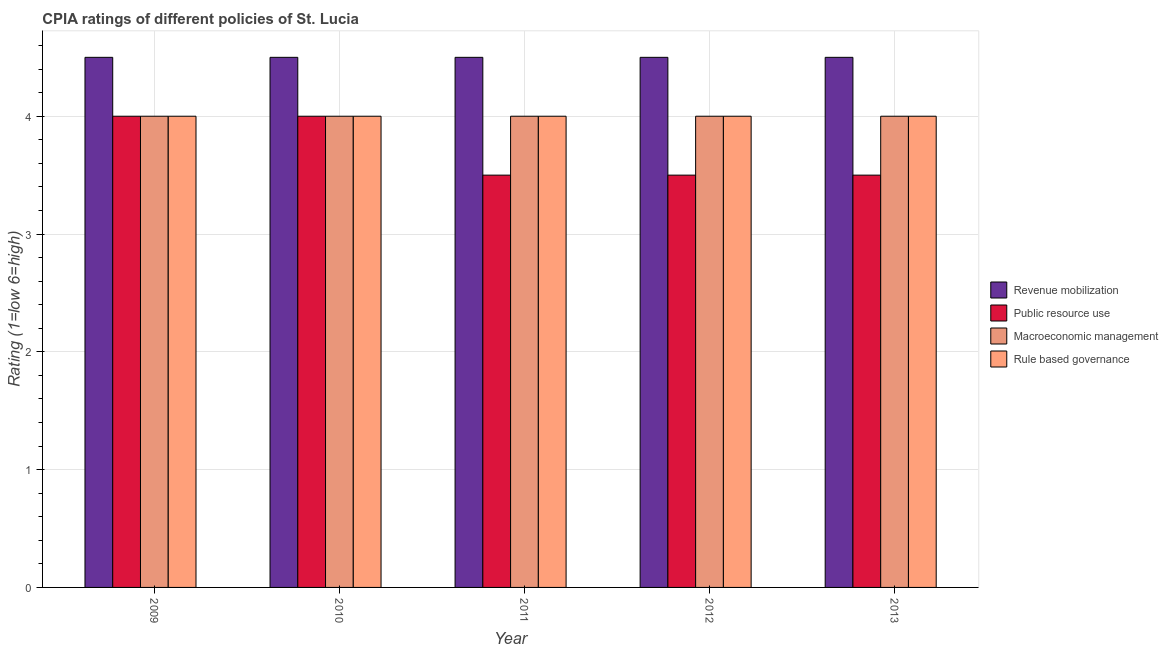How many different coloured bars are there?
Keep it short and to the point. 4. Are the number of bars per tick equal to the number of legend labels?
Your answer should be compact. Yes. Are the number of bars on each tick of the X-axis equal?
Your response must be concise. Yes. How many bars are there on the 5th tick from the left?
Give a very brief answer. 4. What is the label of the 4th group of bars from the left?
Provide a succinct answer. 2012. In how many cases, is the number of bars for a given year not equal to the number of legend labels?
Provide a succinct answer. 0. What is the cpia rating of public resource use in 2012?
Offer a terse response. 3.5. Across all years, what is the maximum cpia rating of rule based governance?
Provide a succinct answer. 4. Across all years, what is the minimum cpia rating of macroeconomic management?
Make the answer very short. 4. In which year was the cpia rating of revenue mobilization minimum?
Offer a terse response. 2009. What is the total cpia rating of public resource use in the graph?
Your answer should be compact. 18.5. What is the difference between the cpia rating of macroeconomic management in 2012 and the cpia rating of rule based governance in 2013?
Provide a short and direct response. 0. In the year 2010, what is the difference between the cpia rating of public resource use and cpia rating of revenue mobilization?
Provide a succinct answer. 0. In how many years, is the cpia rating of revenue mobilization greater than 1.2?
Ensure brevity in your answer.  5. What is the ratio of the cpia rating of revenue mobilization in 2009 to that in 2013?
Give a very brief answer. 1. Is the difference between the cpia rating of macroeconomic management in 2009 and 2011 greater than the difference between the cpia rating of public resource use in 2009 and 2011?
Give a very brief answer. No. What is the difference between the highest and the second highest cpia rating of revenue mobilization?
Provide a succinct answer. 0. What is the difference between the highest and the lowest cpia rating of revenue mobilization?
Your answer should be very brief. 0. Is it the case that in every year, the sum of the cpia rating of revenue mobilization and cpia rating of public resource use is greater than the sum of cpia rating of rule based governance and cpia rating of macroeconomic management?
Your answer should be compact. Yes. What does the 3rd bar from the left in 2010 represents?
Your response must be concise. Macroeconomic management. What does the 3rd bar from the right in 2009 represents?
Offer a terse response. Public resource use. Are all the bars in the graph horizontal?
Give a very brief answer. No. How many years are there in the graph?
Your answer should be compact. 5. Are the values on the major ticks of Y-axis written in scientific E-notation?
Provide a succinct answer. No. Does the graph contain grids?
Your response must be concise. Yes. Where does the legend appear in the graph?
Your answer should be very brief. Center right. How many legend labels are there?
Offer a very short reply. 4. What is the title of the graph?
Provide a succinct answer. CPIA ratings of different policies of St. Lucia. Does "Quality Certification" appear as one of the legend labels in the graph?
Offer a terse response. No. What is the label or title of the X-axis?
Keep it short and to the point. Year. What is the Rating (1=low 6=high) in Revenue mobilization in 2009?
Give a very brief answer. 4.5. What is the Rating (1=low 6=high) in Public resource use in 2009?
Provide a succinct answer. 4. What is the Rating (1=low 6=high) of Macroeconomic management in 2009?
Keep it short and to the point. 4. What is the Rating (1=low 6=high) in Rule based governance in 2009?
Ensure brevity in your answer.  4. What is the Rating (1=low 6=high) of Macroeconomic management in 2011?
Your response must be concise. 4. What is the Rating (1=low 6=high) in Revenue mobilization in 2012?
Ensure brevity in your answer.  4.5. What is the Rating (1=low 6=high) of Public resource use in 2013?
Keep it short and to the point. 3.5. What is the Rating (1=low 6=high) of Macroeconomic management in 2013?
Make the answer very short. 4. Across all years, what is the maximum Rating (1=low 6=high) of Revenue mobilization?
Offer a terse response. 4.5. Across all years, what is the maximum Rating (1=low 6=high) in Macroeconomic management?
Offer a terse response. 4. Across all years, what is the minimum Rating (1=low 6=high) in Revenue mobilization?
Provide a succinct answer. 4.5. Across all years, what is the minimum Rating (1=low 6=high) in Public resource use?
Offer a very short reply. 3.5. Across all years, what is the minimum Rating (1=low 6=high) in Rule based governance?
Your answer should be very brief. 4. What is the total Rating (1=low 6=high) of Revenue mobilization in the graph?
Offer a very short reply. 22.5. What is the total Rating (1=low 6=high) in Public resource use in the graph?
Give a very brief answer. 18.5. What is the difference between the Rating (1=low 6=high) in Revenue mobilization in 2009 and that in 2010?
Your answer should be very brief. 0. What is the difference between the Rating (1=low 6=high) of Public resource use in 2009 and that in 2010?
Provide a succinct answer. 0. What is the difference between the Rating (1=low 6=high) of Rule based governance in 2009 and that in 2010?
Make the answer very short. 0. What is the difference between the Rating (1=low 6=high) in Revenue mobilization in 2009 and that in 2011?
Make the answer very short. 0. What is the difference between the Rating (1=low 6=high) in Public resource use in 2009 and that in 2011?
Your answer should be very brief. 0.5. What is the difference between the Rating (1=low 6=high) of Public resource use in 2009 and that in 2012?
Provide a short and direct response. 0.5. What is the difference between the Rating (1=low 6=high) in Macroeconomic management in 2009 and that in 2012?
Make the answer very short. 0. What is the difference between the Rating (1=low 6=high) of Rule based governance in 2009 and that in 2012?
Provide a succinct answer. 0. What is the difference between the Rating (1=low 6=high) of Revenue mobilization in 2009 and that in 2013?
Your answer should be compact. 0. What is the difference between the Rating (1=low 6=high) in Public resource use in 2009 and that in 2013?
Your answer should be compact. 0.5. What is the difference between the Rating (1=low 6=high) of Macroeconomic management in 2009 and that in 2013?
Your response must be concise. 0. What is the difference between the Rating (1=low 6=high) of Rule based governance in 2009 and that in 2013?
Provide a succinct answer. 0. What is the difference between the Rating (1=low 6=high) in Rule based governance in 2010 and that in 2011?
Make the answer very short. 0. What is the difference between the Rating (1=low 6=high) in Revenue mobilization in 2010 and that in 2012?
Offer a very short reply. 0. What is the difference between the Rating (1=low 6=high) of Revenue mobilization in 2010 and that in 2013?
Keep it short and to the point. 0. What is the difference between the Rating (1=low 6=high) of Public resource use in 2011 and that in 2012?
Your answer should be compact. 0. What is the difference between the Rating (1=low 6=high) of Macroeconomic management in 2011 and that in 2012?
Your answer should be compact. 0. What is the difference between the Rating (1=low 6=high) of Public resource use in 2012 and that in 2013?
Your answer should be very brief. 0. What is the difference between the Rating (1=low 6=high) of Macroeconomic management in 2012 and that in 2013?
Offer a terse response. 0. What is the difference between the Rating (1=low 6=high) in Revenue mobilization in 2009 and the Rating (1=low 6=high) in Public resource use in 2010?
Offer a very short reply. 0.5. What is the difference between the Rating (1=low 6=high) of Revenue mobilization in 2009 and the Rating (1=low 6=high) of Macroeconomic management in 2010?
Offer a very short reply. 0.5. What is the difference between the Rating (1=low 6=high) in Public resource use in 2009 and the Rating (1=low 6=high) in Macroeconomic management in 2010?
Provide a short and direct response. 0. What is the difference between the Rating (1=low 6=high) in Public resource use in 2009 and the Rating (1=low 6=high) in Rule based governance in 2010?
Offer a very short reply. 0. What is the difference between the Rating (1=low 6=high) in Macroeconomic management in 2009 and the Rating (1=low 6=high) in Rule based governance in 2010?
Ensure brevity in your answer.  0. What is the difference between the Rating (1=low 6=high) of Revenue mobilization in 2009 and the Rating (1=low 6=high) of Macroeconomic management in 2011?
Provide a succinct answer. 0.5. What is the difference between the Rating (1=low 6=high) in Revenue mobilization in 2009 and the Rating (1=low 6=high) in Rule based governance in 2011?
Provide a succinct answer. 0.5. What is the difference between the Rating (1=low 6=high) in Public resource use in 2009 and the Rating (1=low 6=high) in Macroeconomic management in 2011?
Provide a short and direct response. 0. What is the difference between the Rating (1=low 6=high) in Public resource use in 2009 and the Rating (1=low 6=high) in Rule based governance in 2011?
Make the answer very short. 0. What is the difference between the Rating (1=low 6=high) in Macroeconomic management in 2009 and the Rating (1=low 6=high) in Rule based governance in 2011?
Offer a terse response. 0. What is the difference between the Rating (1=low 6=high) of Revenue mobilization in 2009 and the Rating (1=low 6=high) of Macroeconomic management in 2012?
Ensure brevity in your answer.  0.5. What is the difference between the Rating (1=low 6=high) in Public resource use in 2009 and the Rating (1=low 6=high) in Rule based governance in 2012?
Your answer should be compact. 0. What is the difference between the Rating (1=low 6=high) of Public resource use in 2009 and the Rating (1=low 6=high) of Macroeconomic management in 2013?
Make the answer very short. 0. What is the difference between the Rating (1=low 6=high) of Public resource use in 2009 and the Rating (1=low 6=high) of Rule based governance in 2013?
Your answer should be compact. 0. What is the difference between the Rating (1=low 6=high) of Revenue mobilization in 2010 and the Rating (1=low 6=high) of Rule based governance in 2011?
Keep it short and to the point. 0.5. What is the difference between the Rating (1=low 6=high) of Public resource use in 2010 and the Rating (1=low 6=high) of Rule based governance in 2011?
Your answer should be compact. 0. What is the difference between the Rating (1=low 6=high) of Macroeconomic management in 2010 and the Rating (1=low 6=high) of Rule based governance in 2011?
Make the answer very short. 0. What is the difference between the Rating (1=low 6=high) in Revenue mobilization in 2010 and the Rating (1=low 6=high) in Macroeconomic management in 2012?
Ensure brevity in your answer.  0.5. What is the difference between the Rating (1=low 6=high) of Macroeconomic management in 2010 and the Rating (1=low 6=high) of Rule based governance in 2012?
Ensure brevity in your answer.  0. What is the difference between the Rating (1=low 6=high) of Revenue mobilization in 2010 and the Rating (1=low 6=high) of Macroeconomic management in 2013?
Offer a terse response. 0.5. What is the difference between the Rating (1=low 6=high) in Public resource use in 2010 and the Rating (1=low 6=high) in Macroeconomic management in 2013?
Provide a short and direct response. 0. What is the difference between the Rating (1=low 6=high) of Public resource use in 2011 and the Rating (1=low 6=high) of Rule based governance in 2012?
Provide a short and direct response. -0.5. What is the difference between the Rating (1=low 6=high) of Macroeconomic management in 2011 and the Rating (1=low 6=high) of Rule based governance in 2013?
Your answer should be very brief. 0. What is the difference between the Rating (1=low 6=high) of Revenue mobilization in 2012 and the Rating (1=low 6=high) of Public resource use in 2013?
Provide a succinct answer. 1. What is the difference between the Rating (1=low 6=high) in Revenue mobilization in 2012 and the Rating (1=low 6=high) in Rule based governance in 2013?
Ensure brevity in your answer.  0.5. What is the difference between the Rating (1=low 6=high) in Public resource use in 2012 and the Rating (1=low 6=high) in Rule based governance in 2013?
Provide a succinct answer. -0.5. What is the average Rating (1=low 6=high) of Revenue mobilization per year?
Give a very brief answer. 4.5. What is the average Rating (1=low 6=high) of Rule based governance per year?
Provide a short and direct response. 4. In the year 2009, what is the difference between the Rating (1=low 6=high) in Revenue mobilization and Rating (1=low 6=high) in Rule based governance?
Your answer should be compact. 0.5. In the year 2009, what is the difference between the Rating (1=low 6=high) of Macroeconomic management and Rating (1=low 6=high) of Rule based governance?
Provide a short and direct response. 0. In the year 2010, what is the difference between the Rating (1=low 6=high) of Revenue mobilization and Rating (1=low 6=high) of Macroeconomic management?
Give a very brief answer. 0.5. In the year 2010, what is the difference between the Rating (1=low 6=high) in Public resource use and Rating (1=low 6=high) in Macroeconomic management?
Offer a very short reply. 0. In the year 2010, what is the difference between the Rating (1=low 6=high) in Macroeconomic management and Rating (1=low 6=high) in Rule based governance?
Provide a short and direct response. 0. In the year 2011, what is the difference between the Rating (1=low 6=high) in Revenue mobilization and Rating (1=low 6=high) in Macroeconomic management?
Your answer should be compact. 0.5. In the year 2011, what is the difference between the Rating (1=low 6=high) of Public resource use and Rating (1=low 6=high) of Rule based governance?
Your response must be concise. -0.5. In the year 2012, what is the difference between the Rating (1=low 6=high) in Revenue mobilization and Rating (1=low 6=high) in Public resource use?
Your answer should be compact. 1. In the year 2012, what is the difference between the Rating (1=low 6=high) in Revenue mobilization and Rating (1=low 6=high) in Rule based governance?
Offer a very short reply. 0.5. In the year 2012, what is the difference between the Rating (1=low 6=high) of Public resource use and Rating (1=low 6=high) of Macroeconomic management?
Give a very brief answer. -0.5. In the year 2012, what is the difference between the Rating (1=low 6=high) in Public resource use and Rating (1=low 6=high) in Rule based governance?
Offer a terse response. -0.5. In the year 2013, what is the difference between the Rating (1=low 6=high) in Revenue mobilization and Rating (1=low 6=high) in Rule based governance?
Ensure brevity in your answer.  0.5. In the year 2013, what is the difference between the Rating (1=low 6=high) in Public resource use and Rating (1=low 6=high) in Rule based governance?
Provide a succinct answer. -0.5. What is the ratio of the Rating (1=low 6=high) of Revenue mobilization in 2009 to that in 2010?
Keep it short and to the point. 1. What is the ratio of the Rating (1=low 6=high) in Rule based governance in 2009 to that in 2010?
Your response must be concise. 1. What is the ratio of the Rating (1=low 6=high) of Revenue mobilization in 2009 to that in 2011?
Give a very brief answer. 1. What is the ratio of the Rating (1=low 6=high) in Rule based governance in 2009 to that in 2012?
Offer a very short reply. 1. What is the ratio of the Rating (1=low 6=high) in Revenue mobilization in 2009 to that in 2013?
Your response must be concise. 1. What is the ratio of the Rating (1=low 6=high) of Public resource use in 2009 to that in 2013?
Offer a terse response. 1.14. What is the ratio of the Rating (1=low 6=high) of Macroeconomic management in 2009 to that in 2013?
Provide a short and direct response. 1. What is the ratio of the Rating (1=low 6=high) of Rule based governance in 2009 to that in 2013?
Your response must be concise. 1. What is the ratio of the Rating (1=low 6=high) in Revenue mobilization in 2010 to that in 2011?
Provide a short and direct response. 1. What is the ratio of the Rating (1=low 6=high) of Public resource use in 2010 to that in 2011?
Give a very brief answer. 1.14. What is the ratio of the Rating (1=low 6=high) in Macroeconomic management in 2010 to that in 2011?
Make the answer very short. 1. What is the ratio of the Rating (1=low 6=high) in Rule based governance in 2010 to that in 2011?
Make the answer very short. 1. What is the ratio of the Rating (1=low 6=high) in Public resource use in 2010 to that in 2012?
Offer a very short reply. 1.14. What is the ratio of the Rating (1=low 6=high) in Rule based governance in 2010 to that in 2012?
Ensure brevity in your answer.  1. What is the ratio of the Rating (1=low 6=high) of Public resource use in 2010 to that in 2013?
Keep it short and to the point. 1.14. What is the ratio of the Rating (1=low 6=high) in Revenue mobilization in 2011 to that in 2012?
Provide a succinct answer. 1. What is the ratio of the Rating (1=low 6=high) of Public resource use in 2011 to that in 2012?
Keep it short and to the point. 1. What is the ratio of the Rating (1=low 6=high) of Rule based governance in 2011 to that in 2012?
Ensure brevity in your answer.  1. What is the ratio of the Rating (1=low 6=high) of Macroeconomic management in 2011 to that in 2013?
Ensure brevity in your answer.  1. What is the ratio of the Rating (1=low 6=high) of Rule based governance in 2011 to that in 2013?
Provide a succinct answer. 1. What is the ratio of the Rating (1=low 6=high) in Revenue mobilization in 2012 to that in 2013?
Make the answer very short. 1. What is the ratio of the Rating (1=low 6=high) in Public resource use in 2012 to that in 2013?
Give a very brief answer. 1. What is the ratio of the Rating (1=low 6=high) in Macroeconomic management in 2012 to that in 2013?
Ensure brevity in your answer.  1. What is the ratio of the Rating (1=low 6=high) of Rule based governance in 2012 to that in 2013?
Offer a very short reply. 1. What is the difference between the highest and the second highest Rating (1=low 6=high) of Public resource use?
Give a very brief answer. 0. What is the difference between the highest and the second highest Rating (1=low 6=high) of Macroeconomic management?
Make the answer very short. 0. What is the difference between the highest and the lowest Rating (1=low 6=high) of Revenue mobilization?
Keep it short and to the point. 0. What is the difference between the highest and the lowest Rating (1=low 6=high) in Macroeconomic management?
Offer a terse response. 0. What is the difference between the highest and the lowest Rating (1=low 6=high) of Rule based governance?
Provide a short and direct response. 0. 